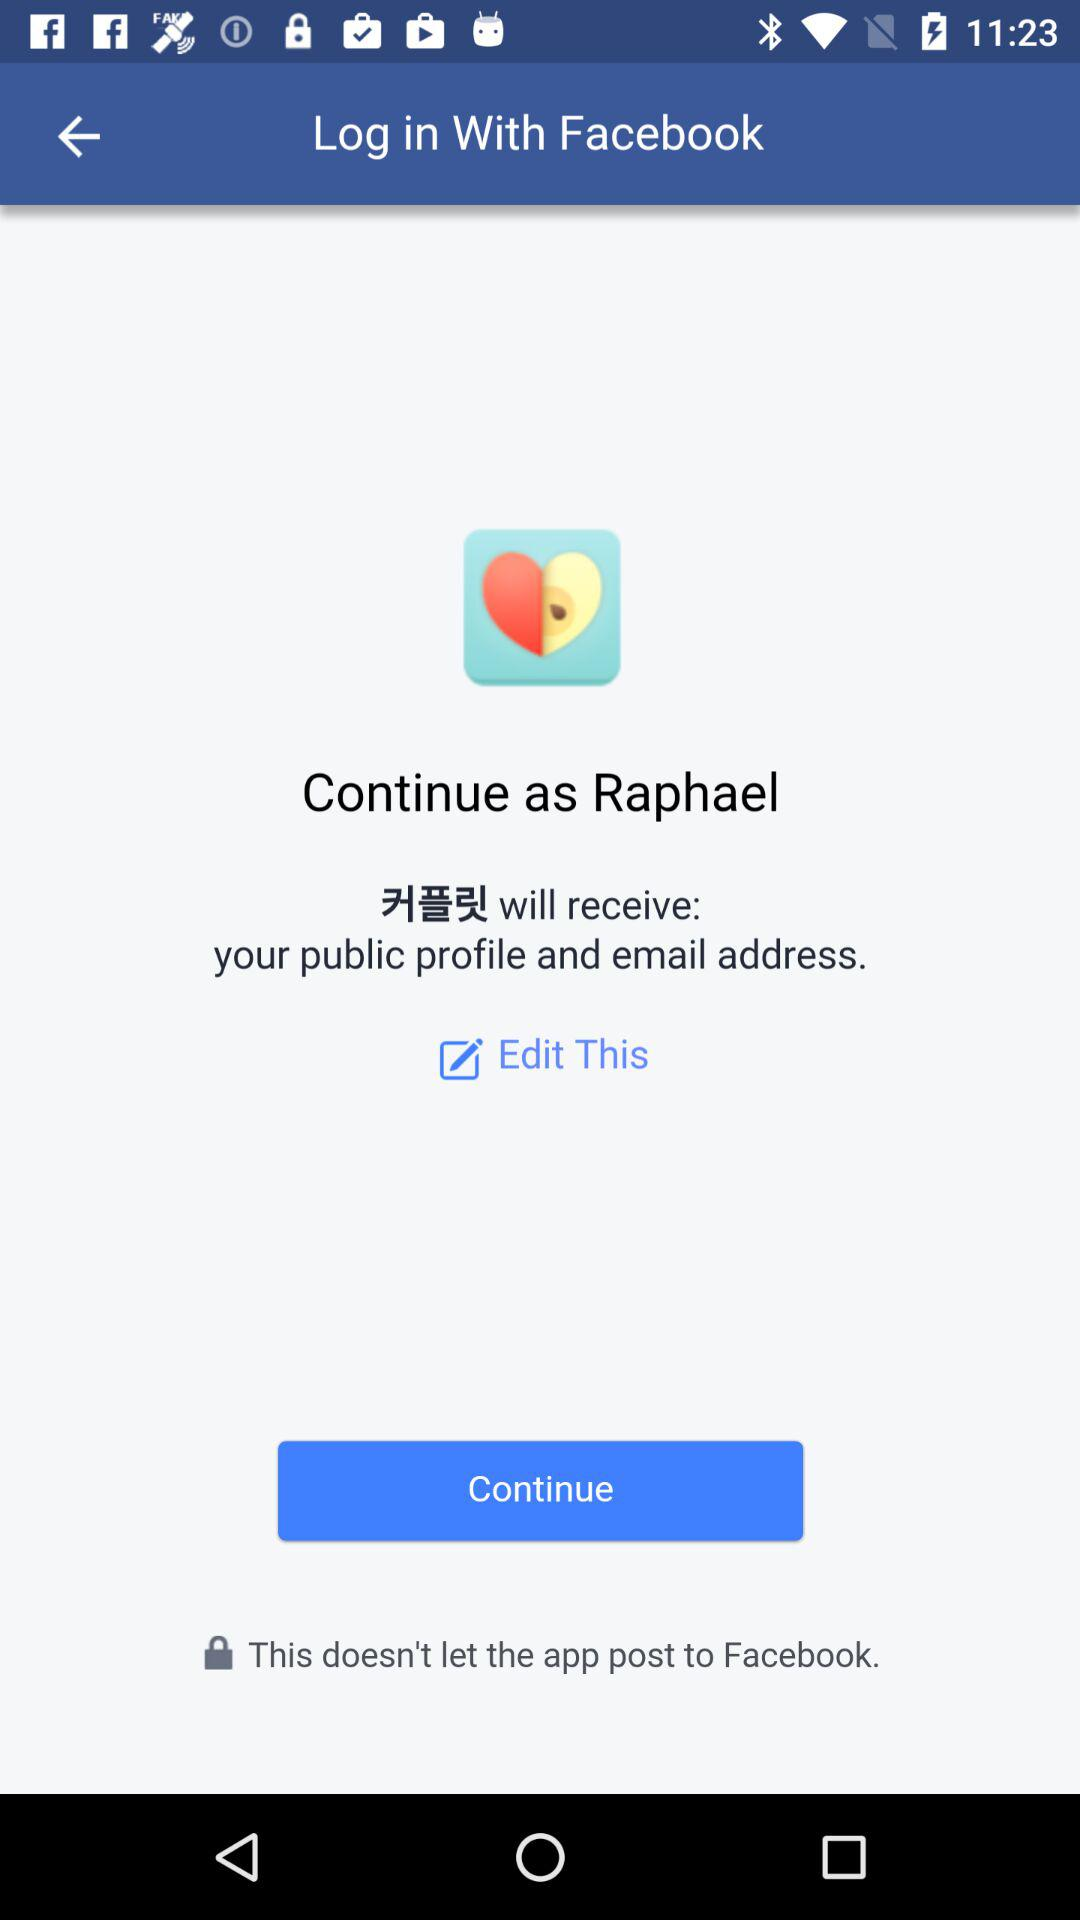What is the user name? The user name is Raphael. 